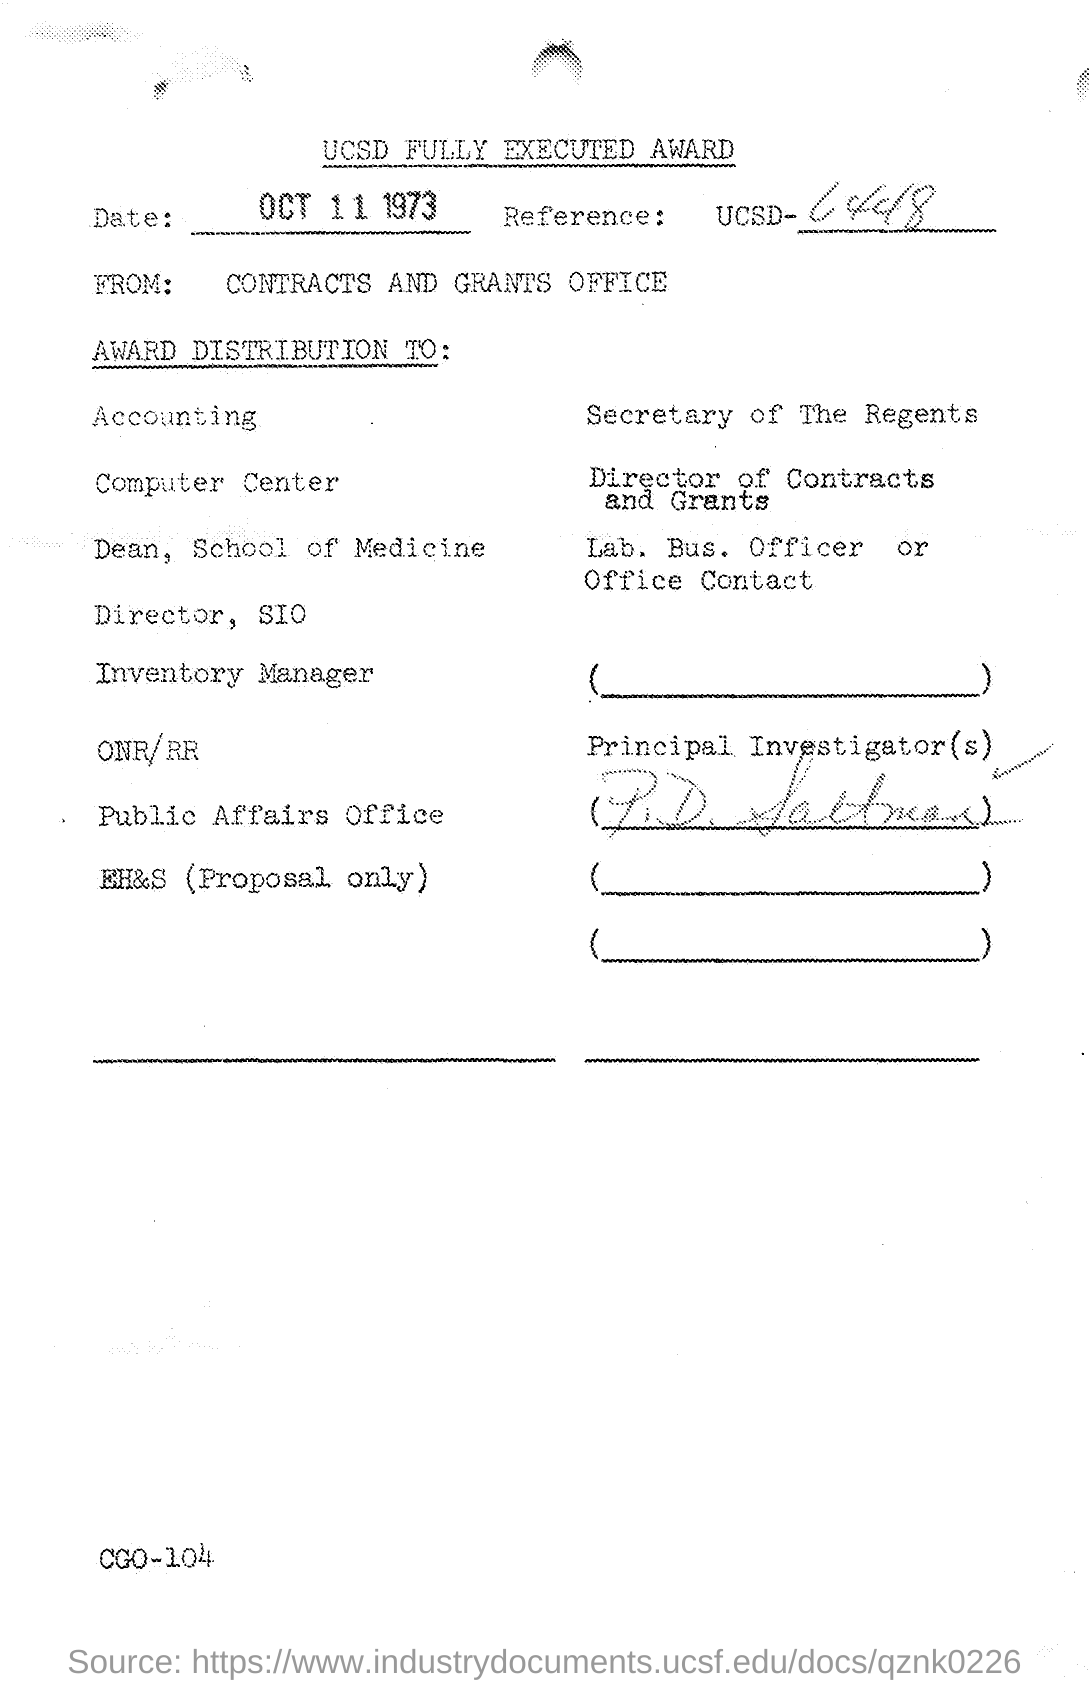What is the date mentioned?
Provide a short and direct response. OCT 11 1973. 